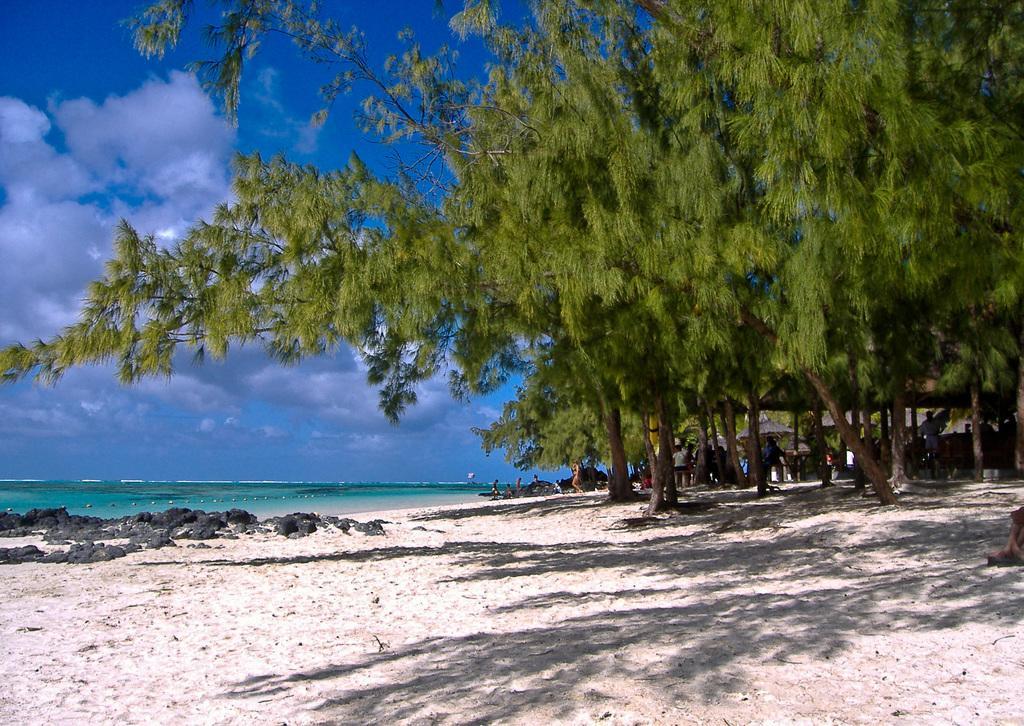Could you give a brief overview of what you see in this image? In the image we can see the sky, clouds, trees, and, water boy and a few people. 